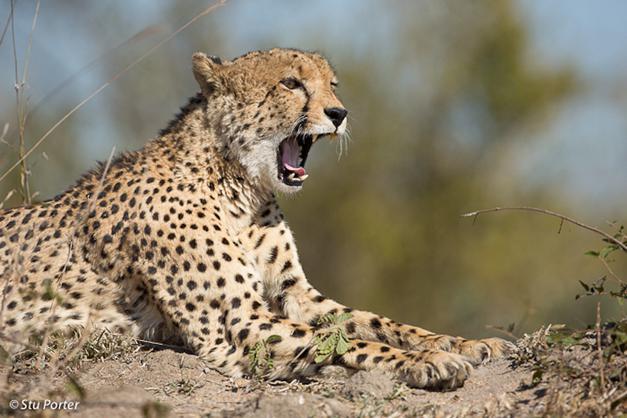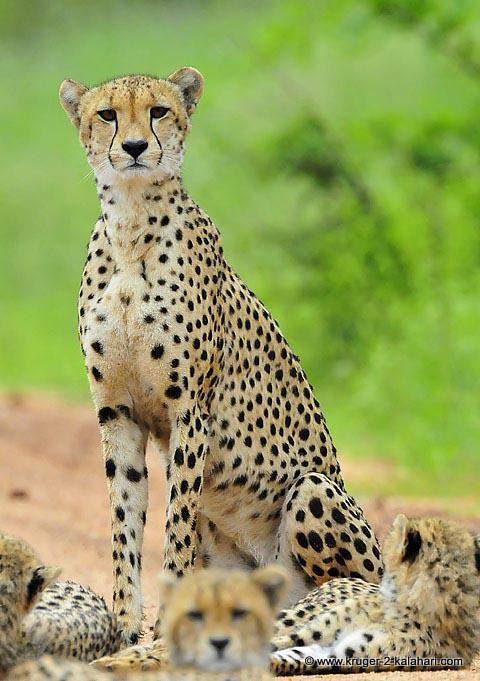The first image is the image on the left, the second image is the image on the right. Examine the images to the left and right. Is the description "The left image includes exactly one spotted wild cat." accurate? Answer yes or no. Yes. The first image is the image on the left, the second image is the image on the right. Assess this claim about the two images: "The leopard in the image on the left is sitting with her kittens.". Correct or not? Answer yes or no. No. 